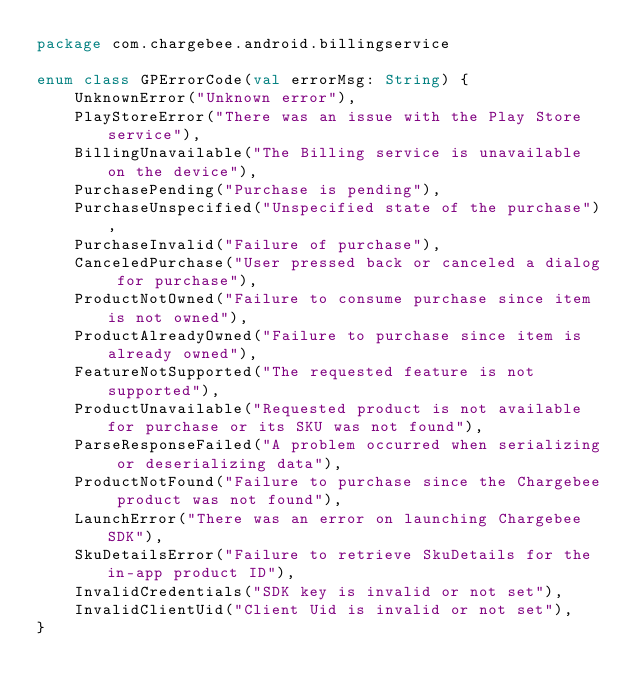Convert code to text. <code><loc_0><loc_0><loc_500><loc_500><_Kotlin_>package com.chargebee.android.billingservice

enum class GPErrorCode(val errorMsg: String) {
    UnknownError("Unknown error"),
    PlayStoreError("There was an issue with the Play Store service"),
    BillingUnavailable("The Billing service is unavailable on the device"),
    PurchasePending("Purchase is pending"),
    PurchaseUnspecified("Unspecified state of the purchase"),
    PurchaseInvalid("Failure of purchase"),
    CanceledPurchase("User pressed back or canceled a dialog for purchase"),
    ProductNotOwned("Failure to consume purchase since item is not owned"),
    ProductAlreadyOwned("Failure to purchase since item is already owned"),
    FeatureNotSupported("The requested feature is not supported"),
    ProductUnavailable("Requested product is not available for purchase or its SKU was not found"),
    ParseResponseFailed("A problem occurred when serializing or deserializing data"),
    ProductNotFound("Failure to purchase since the Chargebee product was not found"),
    LaunchError("There was an error on launching Chargebee SDK"),
    SkuDetailsError("Failure to retrieve SkuDetails for the in-app product ID"),
    InvalidCredentials("SDK key is invalid or not set"),
    InvalidClientUid("Client Uid is invalid or not set"),
}</code> 